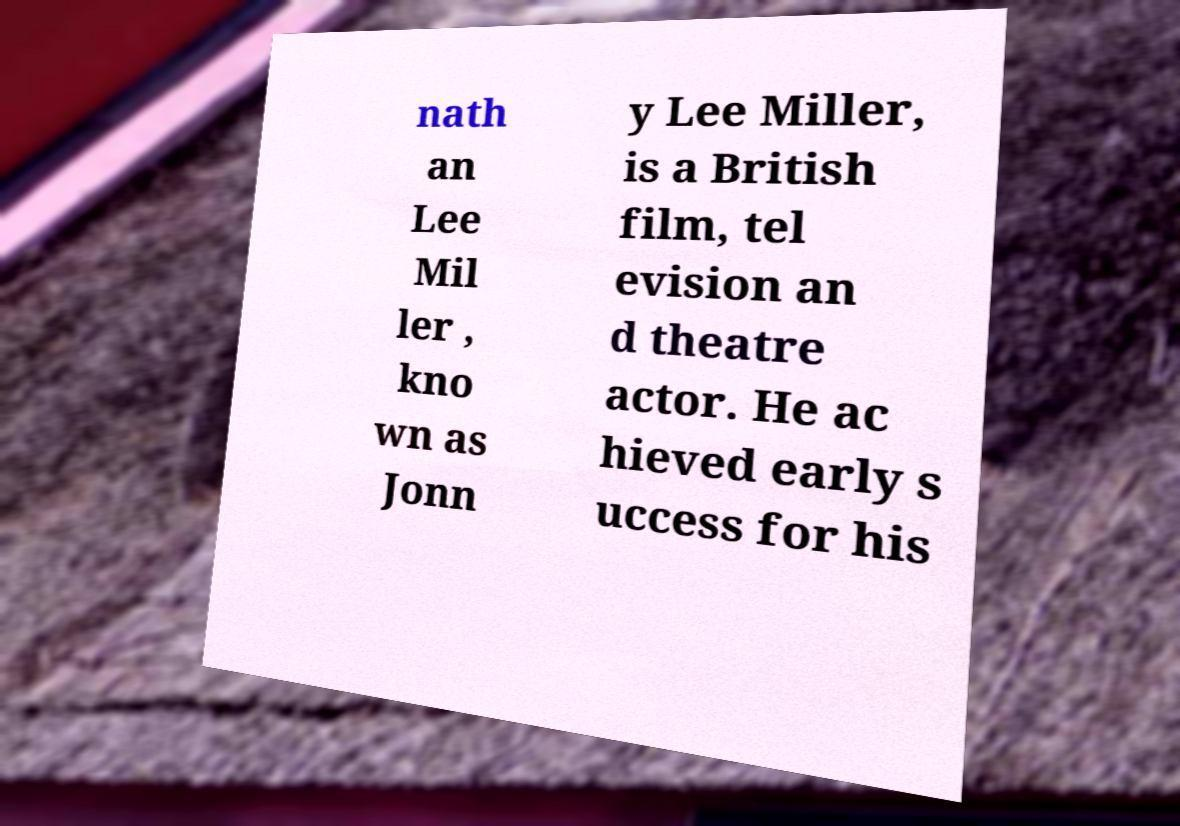What messages or text are displayed in this image? I need them in a readable, typed format. nath an Lee Mil ler , kno wn as Jonn y Lee Miller, is a British film, tel evision an d theatre actor. He ac hieved early s uccess for his 